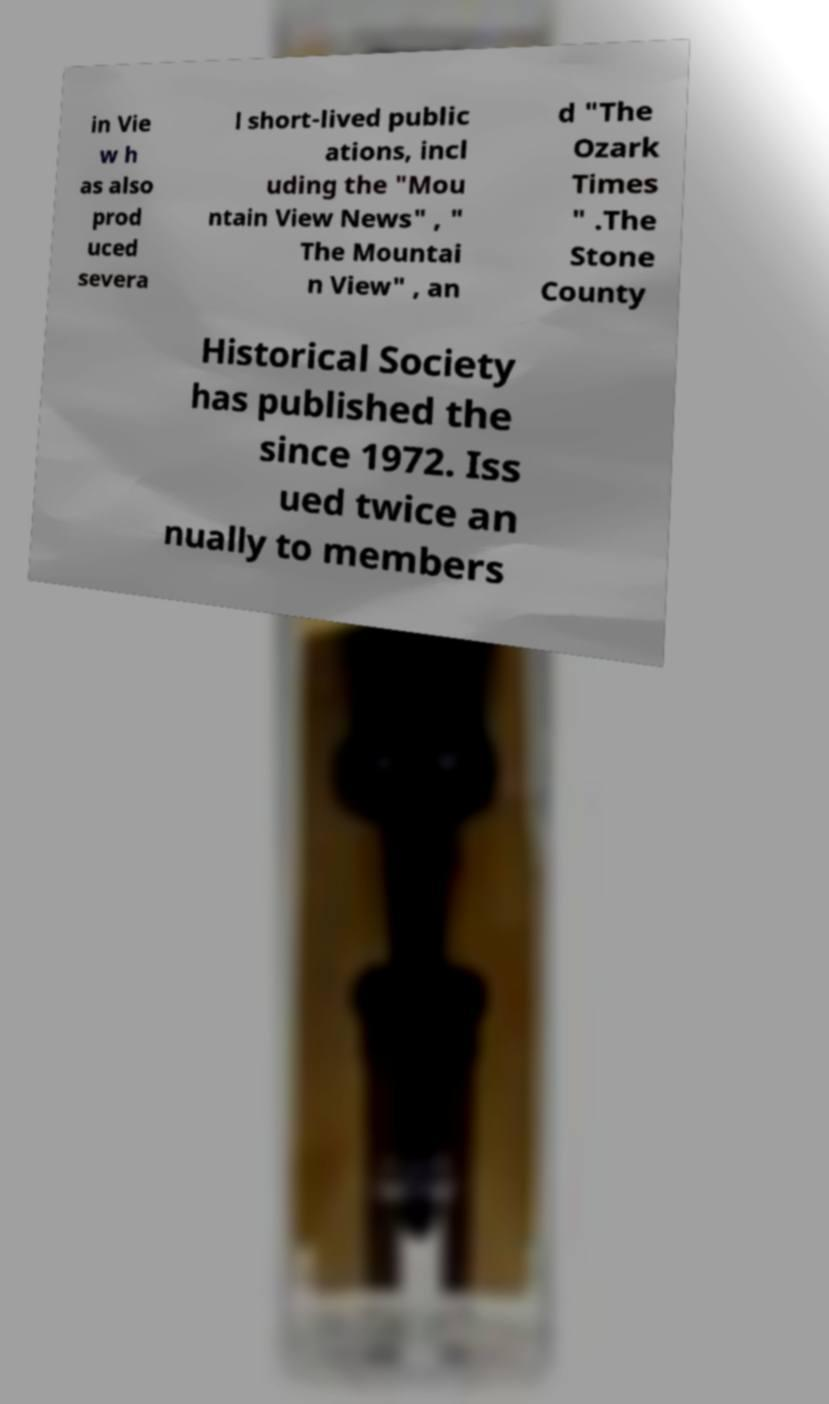I need the written content from this picture converted into text. Can you do that? in Vie w h as also prod uced severa l short-lived public ations, incl uding the "Mou ntain View News" , " The Mountai n View" , an d "The Ozark Times " .The Stone County Historical Society has published the since 1972. Iss ued twice an nually to members 